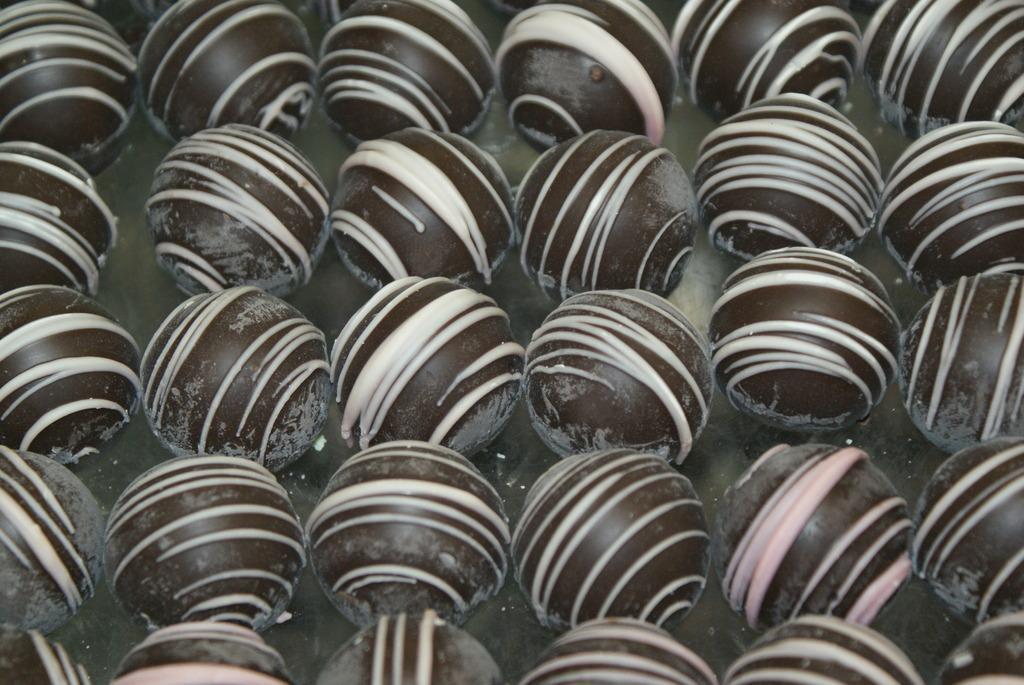Please provide a concise description of this image. In this image I can see round shaped objects on a surface. 